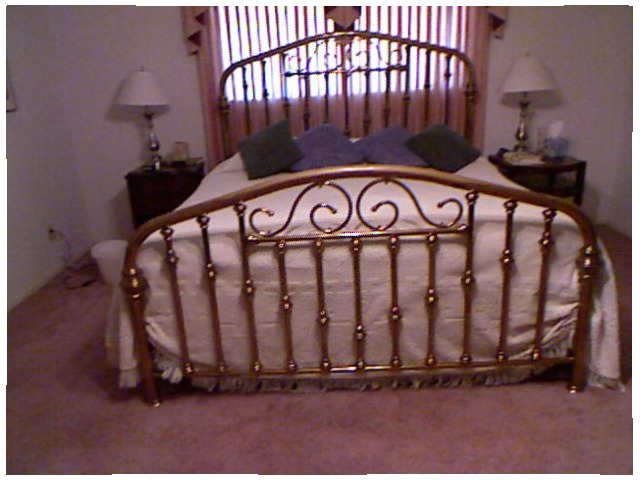<image>
Can you confirm if the bed is behind the lamp? No. The bed is not behind the lamp. From this viewpoint, the bed appears to be positioned elsewhere in the scene. 